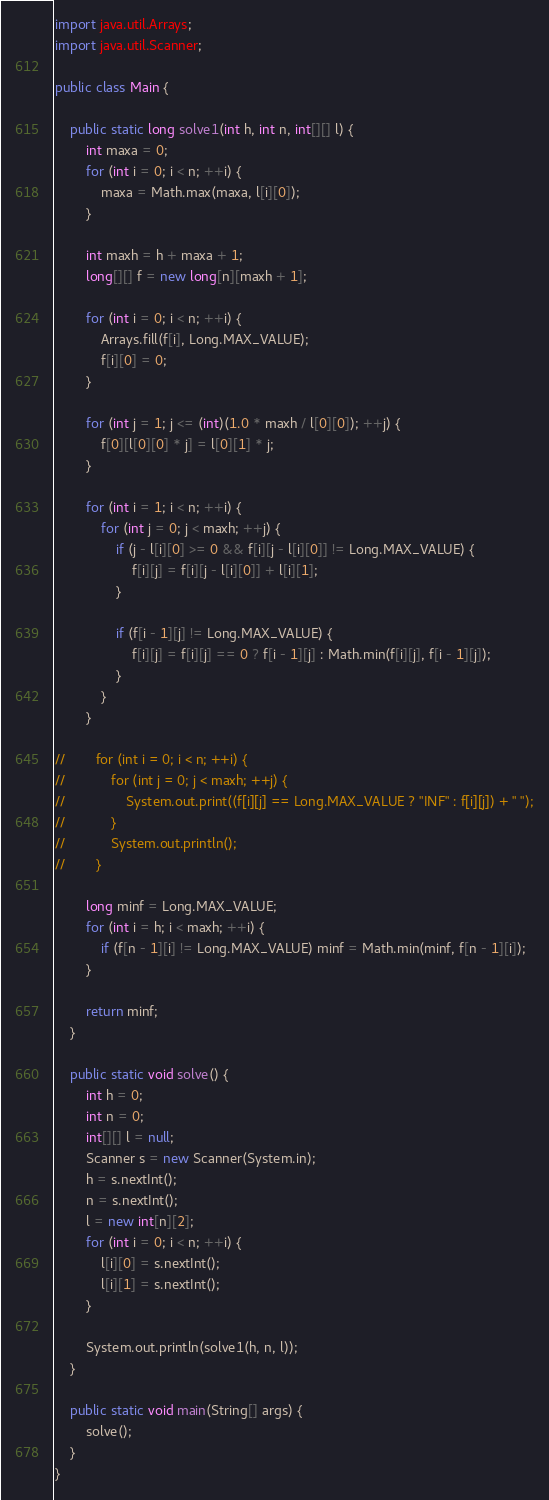Convert code to text. <code><loc_0><loc_0><loc_500><loc_500><_Java_>import java.util.Arrays;
import java.util.Scanner;

public class Main {

    public static long solve1(int h, int n, int[][] l) {
        int maxa = 0;
        for (int i = 0; i < n; ++i) {
            maxa = Math.max(maxa, l[i][0]);
        }

        int maxh = h + maxa + 1;
        long[][] f = new long[n][maxh + 1];

        for (int i = 0; i < n; ++i) {
            Arrays.fill(f[i], Long.MAX_VALUE);
            f[i][0] = 0;
        }

        for (int j = 1; j <= (int)(1.0 * maxh / l[0][0]); ++j) {
            f[0][l[0][0] * j] = l[0][1] * j;
        }

        for (int i = 1; i < n; ++i) {
            for (int j = 0; j < maxh; ++j) {
                if (j - l[i][0] >= 0 && f[i][j - l[i][0]] != Long.MAX_VALUE) {
                    f[i][j] = f[i][j - l[i][0]] + l[i][1];
                }

                if (f[i - 1][j] != Long.MAX_VALUE) {
                    f[i][j] = f[i][j] == 0 ? f[i - 1][j] : Math.min(f[i][j], f[i - 1][j]);
                }
            }
        }

//        for (int i = 0; i < n; ++i) {
//            for (int j = 0; j < maxh; ++j) {
//                System.out.print((f[i][j] == Long.MAX_VALUE ? "INF" : f[i][j]) + " ");
//            }
//            System.out.println();
//        }

        long minf = Long.MAX_VALUE;
        for (int i = h; i < maxh; ++i) {
            if (f[n - 1][i] != Long.MAX_VALUE) minf = Math.min(minf, f[n - 1][i]);
        }

        return minf;
    }

    public static void solve() {
        int h = 0;
        int n = 0;
        int[][] l = null;
        Scanner s = new Scanner(System.in);
        h = s.nextInt();
        n = s.nextInt();
        l = new int[n][2];
        for (int i = 0; i < n; ++i) {
            l[i][0] = s.nextInt();
            l[i][1] = s.nextInt();
        }

        System.out.println(solve1(h, n, l));
    }

    public static void main(String[] args) {
        solve();
    }
}
</code> 